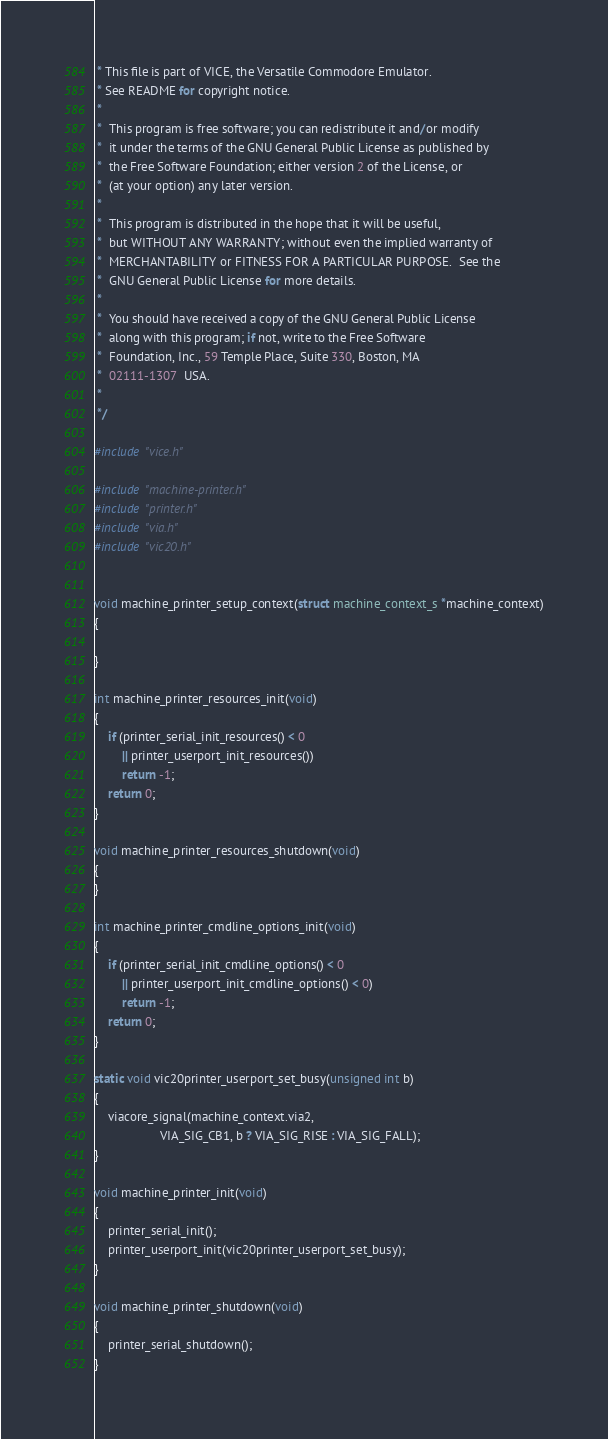<code> <loc_0><loc_0><loc_500><loc_500><_C_> * This file is part of VICE, the Versatile Commodore Emulator.
 * See README for copyright notice.
 *
 *  This program is free software; you can redistribute it and/or modify
 *  it under the terms of the GNU General Public License as published by
 *  the Free Software Foundation; either version 2 of the License, or
 *  (at your option) any later version.
 *
 *  This program is distributed in the hope that it will be useful,
 *  but WITHOUT ANY WARRANTY; without even the implied warranty of
 *  MERCHANTABILITY or FITNESS FOR A PARTICULAR PURPOSE.  See the
 *  GNU General Public License for more details.
 *
 *  You should have received a copy of the GNU General Public License
 *  along with this program; if not, write to the Free Software
 *  Foundation, Inc., 59 Temple Place, Suite 330, Boston, MA
 *  02111-1307  USA.
 *
 */

#include "vice.h"

#include "machine-printer.h"
#include "printer.h"
#include "via.h"
#include "vic20.h"


void machine_printer_setup_context(struct machine_context_s *machine_context)
{

}

int machine_printer_resources_init(void)
{
    if (printer_serial_init_resources() < 0
        || printer_userport_init_resources())
        return -1;
    return 0;
}

void machine_printer_resources_shutdown(void)
{
}

int machine_printer_cmdline_options_init(void)
{
    if (printer_serial_init_cmdline_options() < 0
        || printer_userport_init_cmdline_options() < 0)
        return -1;
    return 0;
}

static void vic20printer_userport_set_busy(unsigned int b)
{
    viacore_signal(machine_context.via2,
                   VIA_SIG_CB1, b ? VIA_SIG_RISE : VIA_SIG_FALL);
}

void machine_printer_init(void)
{
    printer_serial_init();
    printer_userport_init(vic20printer_userport_set_busy);
}

void machine_printer_shutdown(void)
{
    printer_serial_shutdown();
}

</code> 